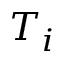Convert formula to latex. <formula><loc_0><loc_0><loc_500><loc_500>T _ { i }</formula> 